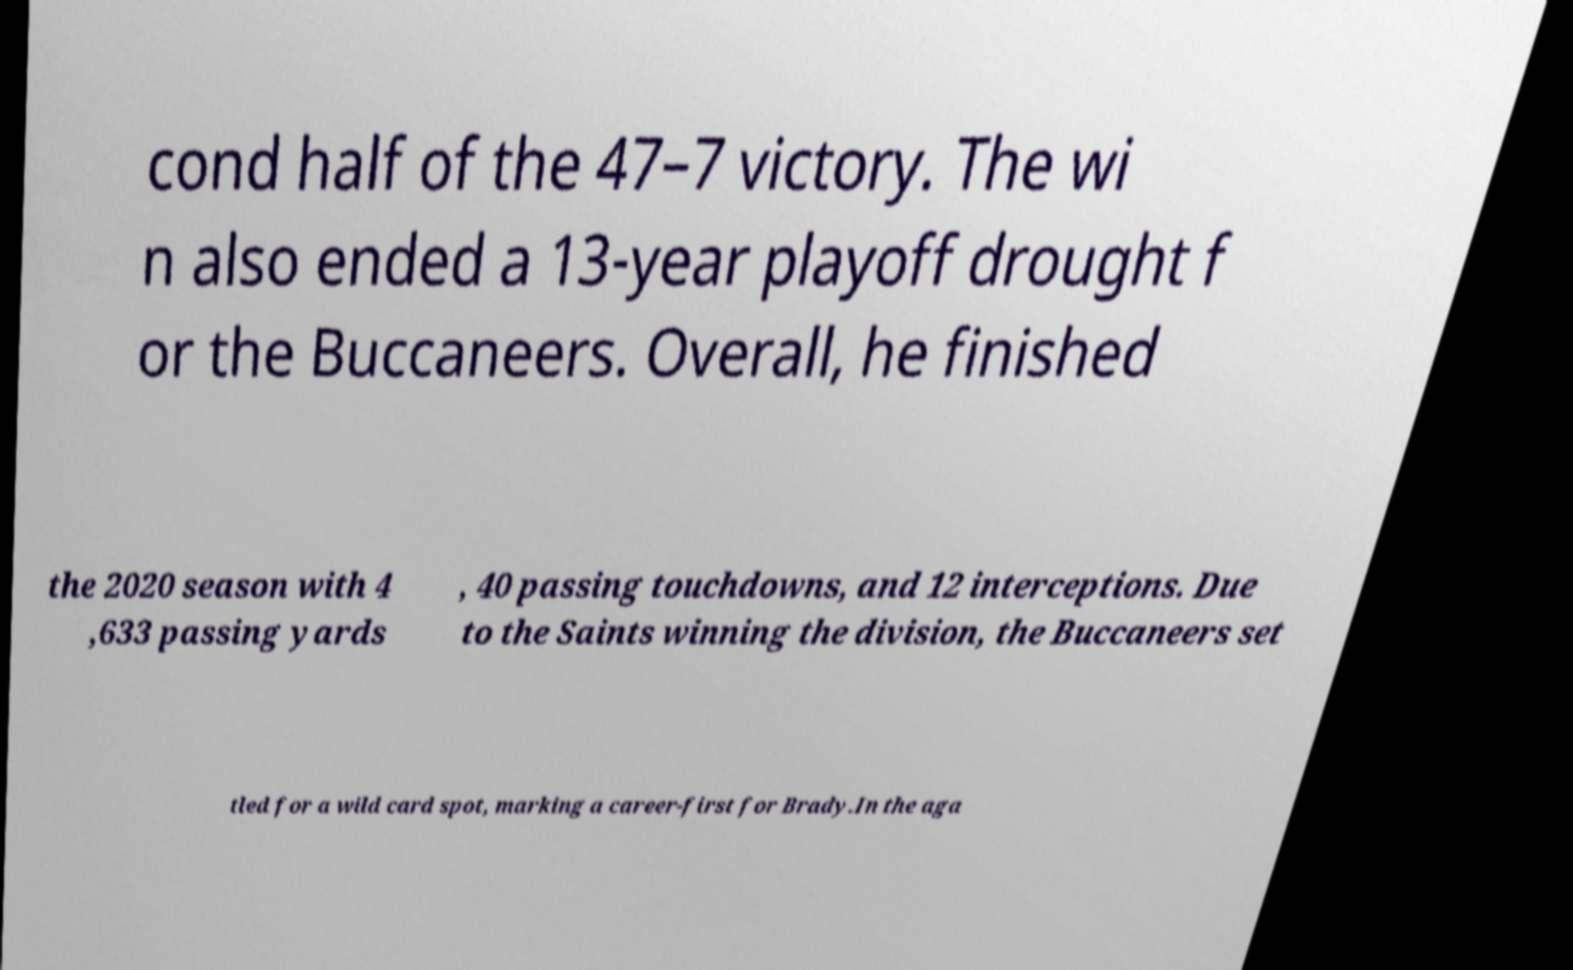Could you extract and type out the text from this image? cond half of the 47–7 victory. The wi n also ended a 13-year playoff drought f or the Buccaneers. Overall, he finished the 2020 season with 4 ,633 passing yards , 40 passing touchdowns, and 12 interceptions. Due to the Saints winning the division, the Buccaneers set tled for a wild card spot, marking a career-first for Brady.In the aga 